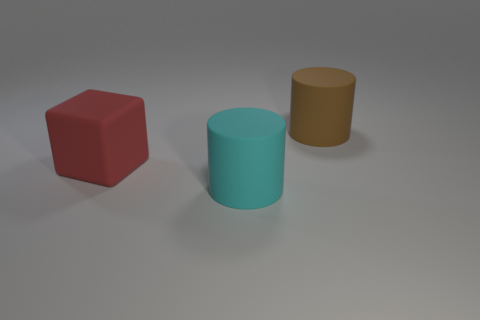What number of matte things are big blue spheres or large objects?
Your response must be concise. 3. What number of brown objects have the same size as the cyan object?
Offer a very short reply. 1. What color is the thing that is right of the big red thing and on the left side of the big brown rubber thing?
Make the answer very short. Cyan. How many things are either yellow matte things or cyan rubber things?
Keep it short and to the point. 1. How many tiny things are brown things or red matte cubes?
Give a very brief answer. 0. Is there any other thing that has the same color as the matte block?
Offer a very short reply. No. What is the size of the rubber object that is right of the large block and in front of the big brown rubber cylinder?
Offer a very short reply. Large. There is a large rubber object behind the red matte object; does it have the same color as the block on the left side of the large cyan matte cylinder?
Offer a very short reply. No. How many other objects are the same material as the large cyan object?
Keep it short and to the point. 2. What shape is the big matte object that is in front of the large brown matte cylinder and behind the big cyan cylinder?
Make the answer very short. Cube. 